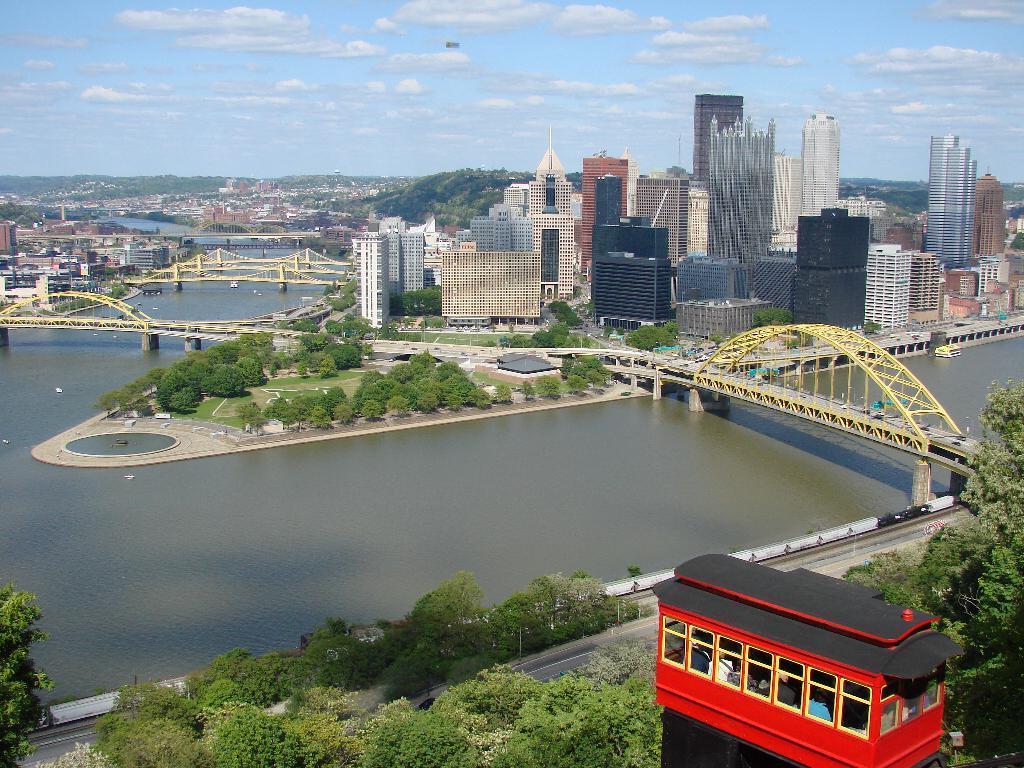Could you give a brief overview of what you see in this image? In this image we can see a lake with some bridges and pillars. We can also see some trees, road, buildings and the sky which looks cloudy. 